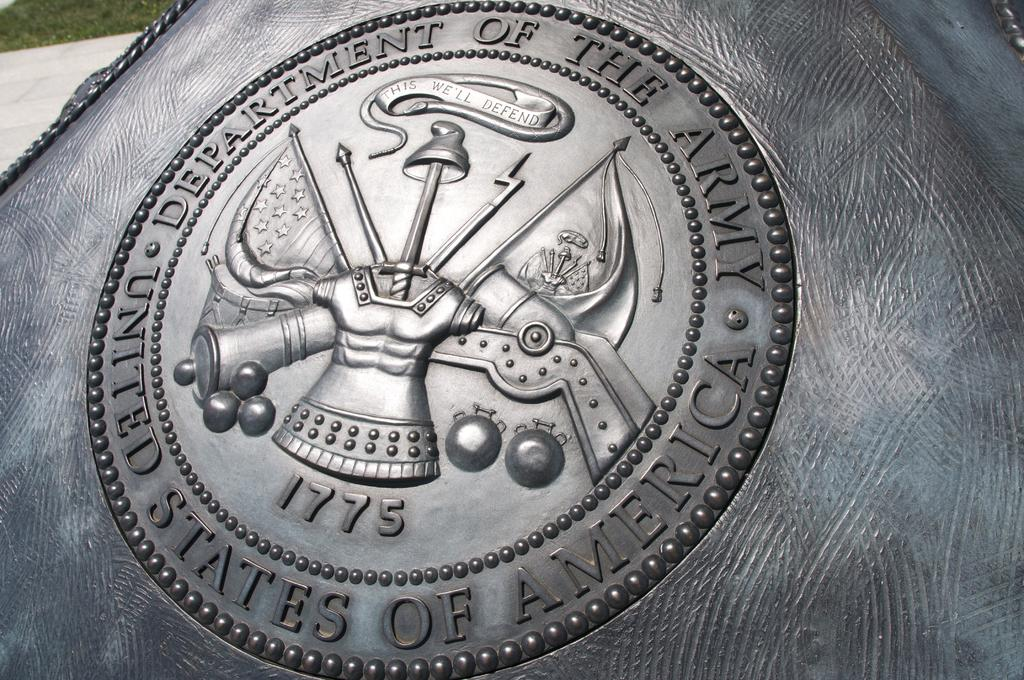<image>
Write a terse but informative summary of the picture. An insignia for the United States Department of the Army. 